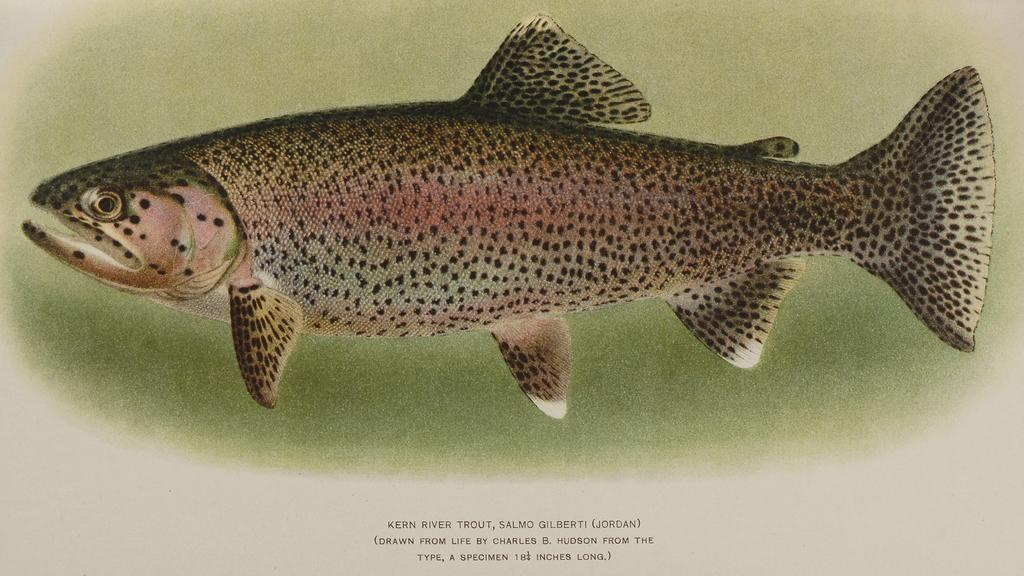What is the main subject of the image? The main subject of the image is a picture of a fish. Is there any text associated with the image? Yes, there is some text at the bottom of the image. How many fingers can be seen touching the fish in the image? There are no fingers or hands visible in the image; it only features a picture of a fish and some text. 